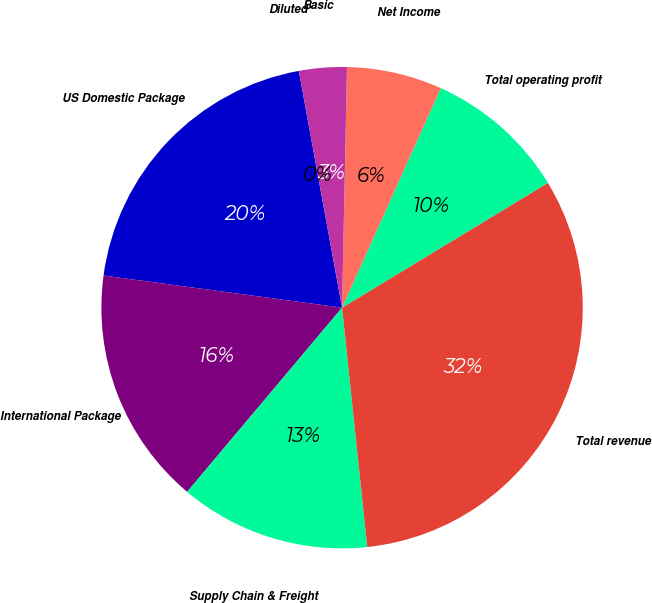<chart> <loc_0><loc_0><loc_500><loc_500><pie_chart><fcel>US Domestic Package<fcel>International Package<fcel>Supply Chain & Freight<fcel>Total revenue<fcel>Total operating profit<fcel>Net Income<fcel>Basic<fcel>Diluted<nl><fcel>19.99%<fcel>16.0%<fcel>12.8%<fcel>32.0%<fcel>9.6%<fcel>6.4%<fcel>3.2%<fcel>0.0%<nl></chart> 